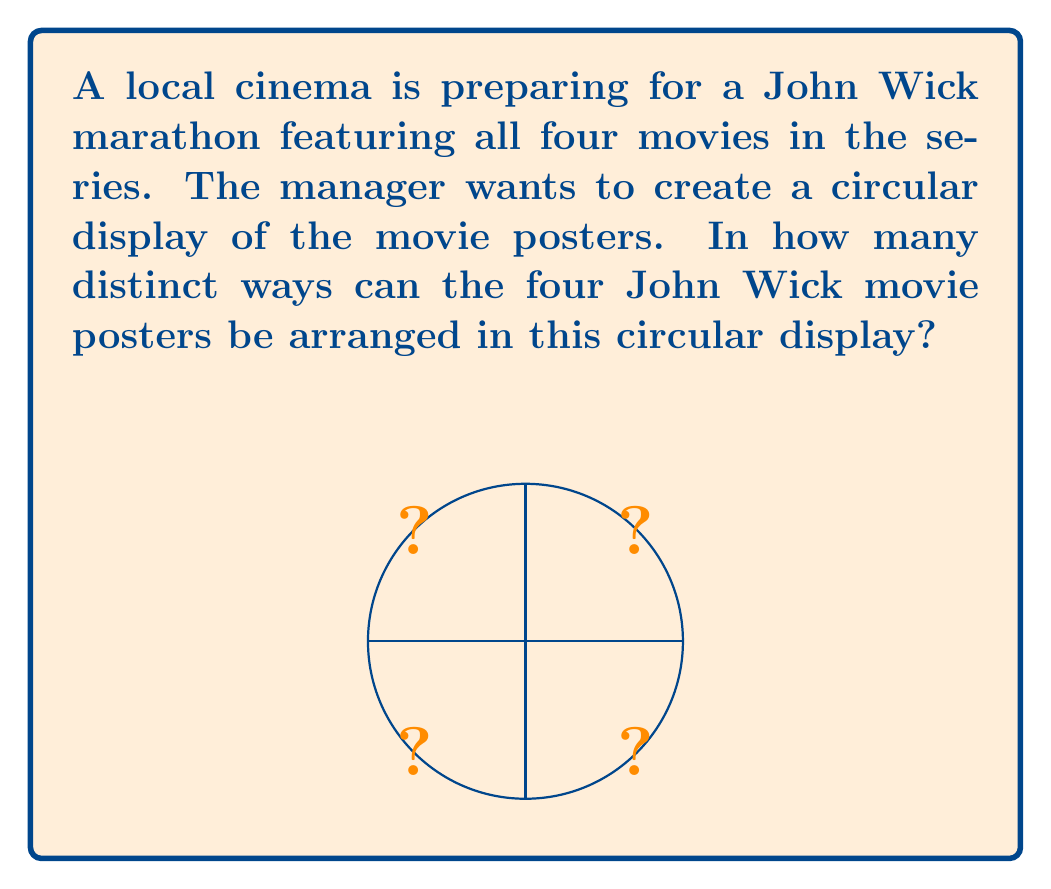Help me with this question. Let's approach this step-by-step:

1) First, we need to understand that in a circular arrangement, rotations of the same arrangement are considered identical. For example, if we have posters A, B, C, and D, then ABCD, BCDA, CDAB, and DABC are all considered the same arrangement.

2) This problem is related to the concept of cyclic permutations in group theory.

3) For $n$ distinct objects, the number of distinct circular arrangements is given by $(n-1)!$

4) In this case, we have 4 distinct movie posters (one for each John Wick movie).

5) Therefore, $n = 4$

6) Applying the formula:
   Number of distinct arrangements = $(4-1)!$
                                   = $3!$
                                   = $3 \times 2 \times 1$
                                   = $6$

Thus, there are 6 distinct ways to arrange the four John Wick movie posters in a circular display.
Answer: $6$ 